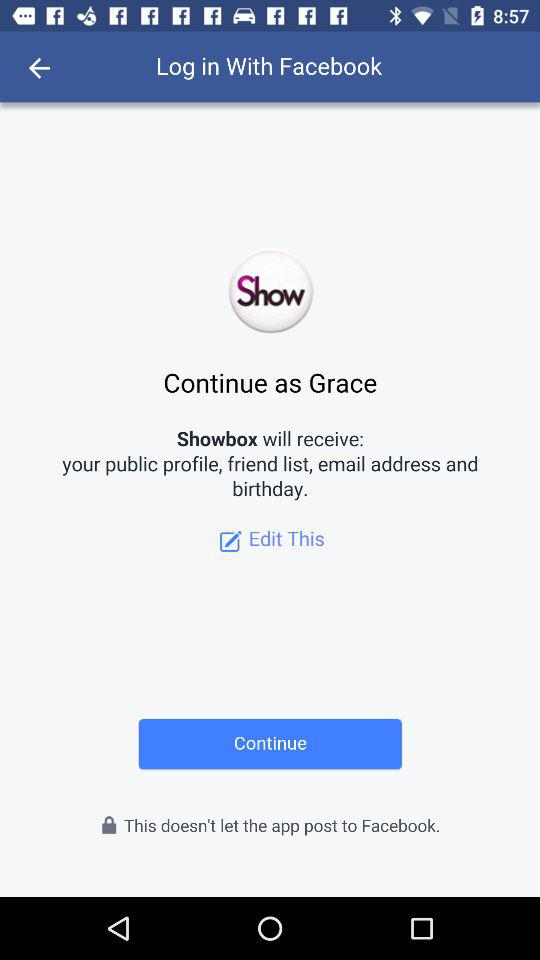What is the name of the user? The name of the user is Grace. 